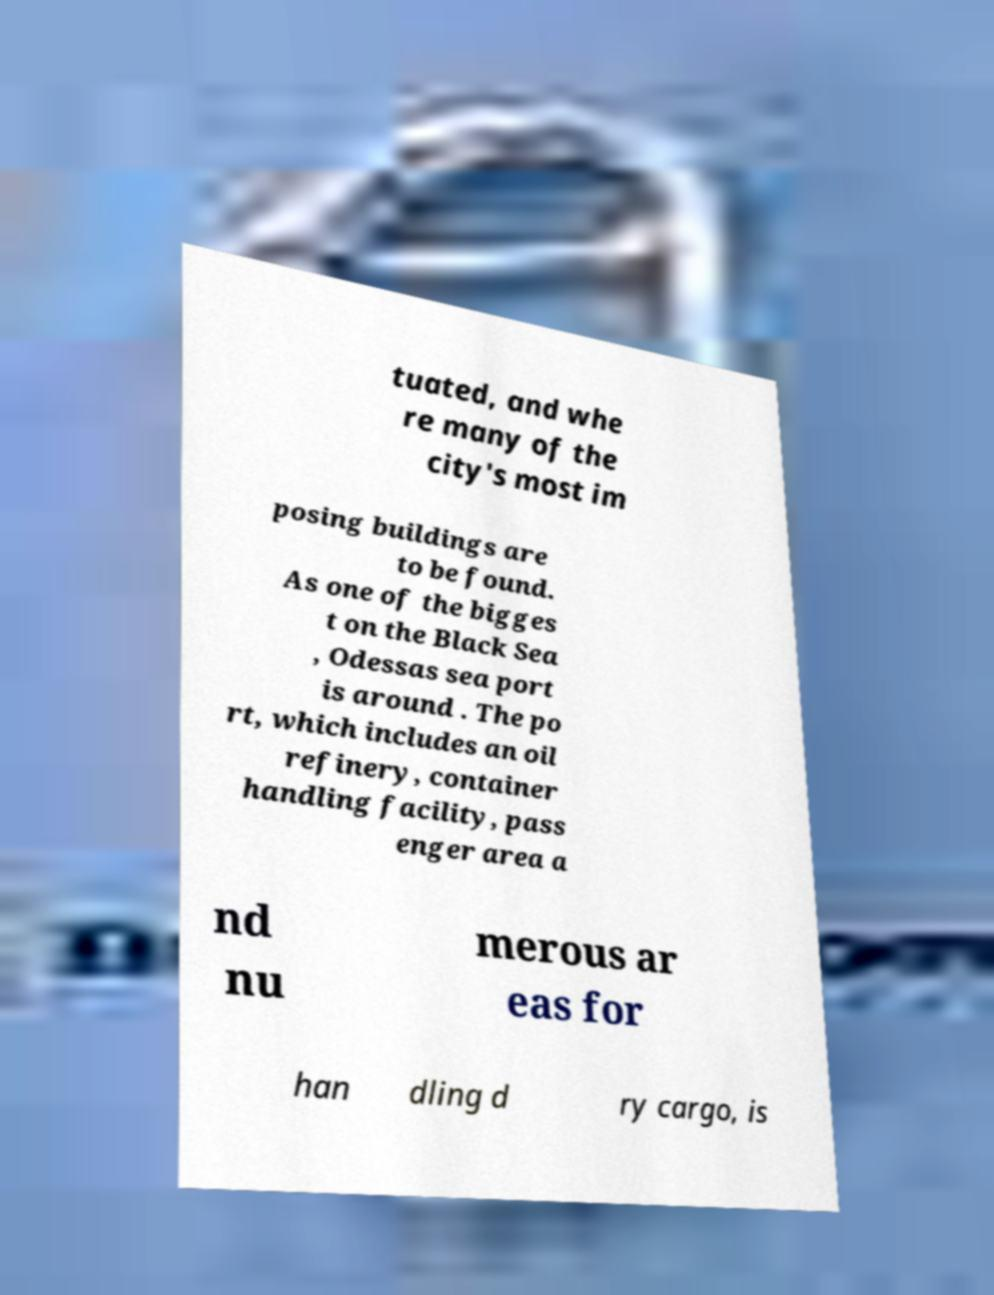What messages or text are displayed in this image? I need them in a readable, typed format. tuated, and whe re many of the city's most im posing buildings are to be found. As one of the bigges t on the Black Sea , Odessas sea port is around . The po rt, which includes an oil refinery, container handling facility, pass enger area a nd nu merous ar eas for han dling d ry cargo, is 